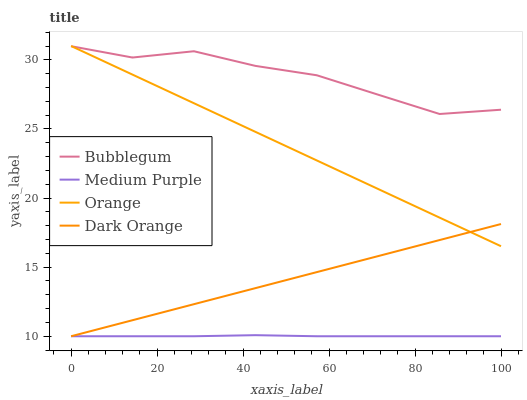Does Medium Purple have the minimum area under the curve?
Answer yes or no. Yes. Does Bubblegum have the maximum area under the curve?
Answer yes or no. Yes. Does Orange have the minimum area under the curve?
Answer yes or no. No. Does Orange have the maximum area under the curve?
Answer yes or no. No. Is Dark Orange the smoothest?
Answer yes or no. Yes. Is Bubblegum the roughest?
Answer yes or no. Yes. Is Orange the smoothest?
Answer yes or no. No. Is Orange the roughest?
Answer yes or no. No. Does Medium Purple have the lowest value?
Answer yes or no. Yes. Does Orange have the lowest value?
Answer yes or no. No. Does Orange have the highest value?
Answer yes or no. Yes. Does Bubblegum have the highest value?
Answer yes or no. No. Is Medium Purple less than Bubblegum?
Answer yes or no. Yes. Is Bubblegum greater than Medium Purple?
Answer yes or no. Yes. Does Orange intersect Bubblegum?
Answer yes or no. Yes. Is Orange less than Bubblegum?
Answer yes or no. No. Is Orange greater than Bubblegum?
Answer yes or no. No. Does Medium Purple intersect Bubblegum?
Answer yes or no. No. 